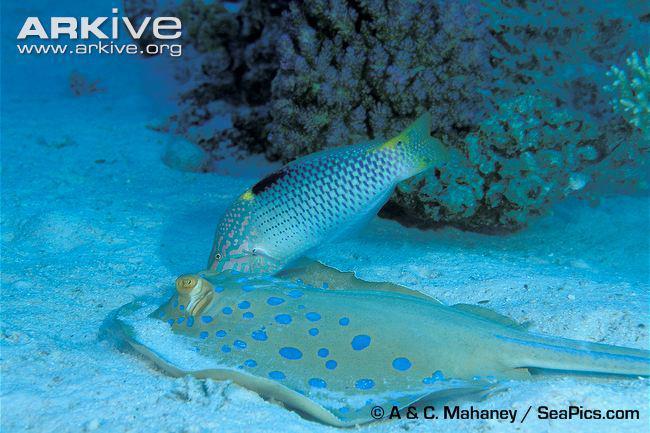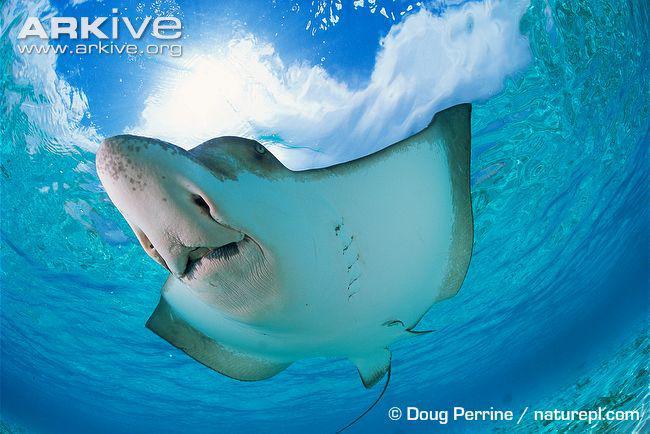The first image is the image on the left, the second image is the image on the right. For the images shown, is this caption "A person whose head and chest are above water is behind a stingray in the ocean." true? Answer yes or no. No. The first image is the image on the left, the second image is the image on the right. Evaluate the accuracy of this statement regarding the images: "An image contains a human touching a sting ray.". Is it true? Answer yes or no. No. 